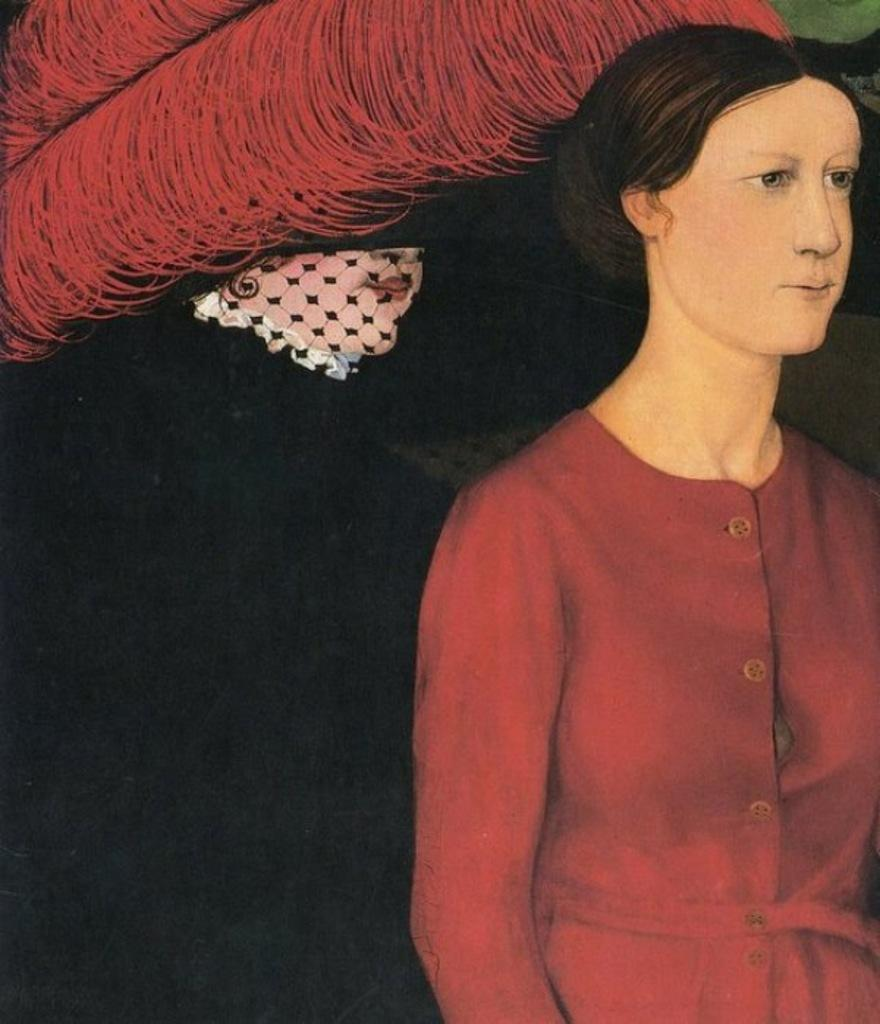What is the main subject of the image? There is a painting in the image. What does the painting depict? The painting depicts a woman. What type of agreement is shown between the woman and the painting in the image? There is no agreement between the woman and the painting in the image, as the painting is a static representation of a woman. 